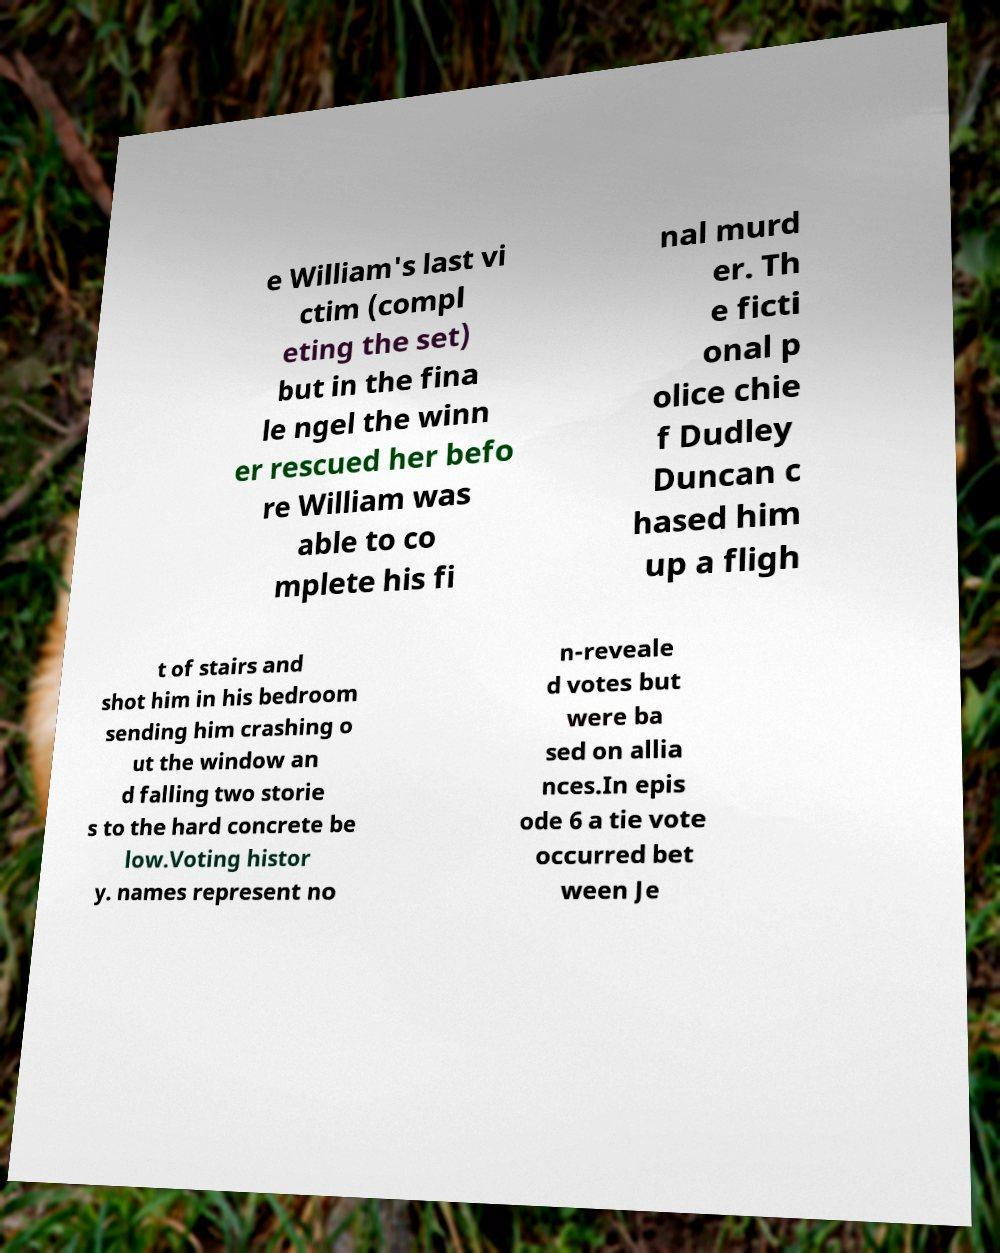What messages or text are displayed in this image? I need them in a readable, typed format. e William's last vi ctim (compl eting the set) but in the fina le ngel the winn er rescued her befo re William was able to co mplete his fi nal murd er. Th e ficti onal p olice chie f Dudley Duncan c hased him up a fligh t of stairs and shot him in his bedroom sending him crashing o ut the window an d falling two storie s to the hard concrete be low.Voting histor y. names represent no n-reveale d votes but were ba sed on allia nces.In epis ode 6 a tie vote occurred bet ween Je 